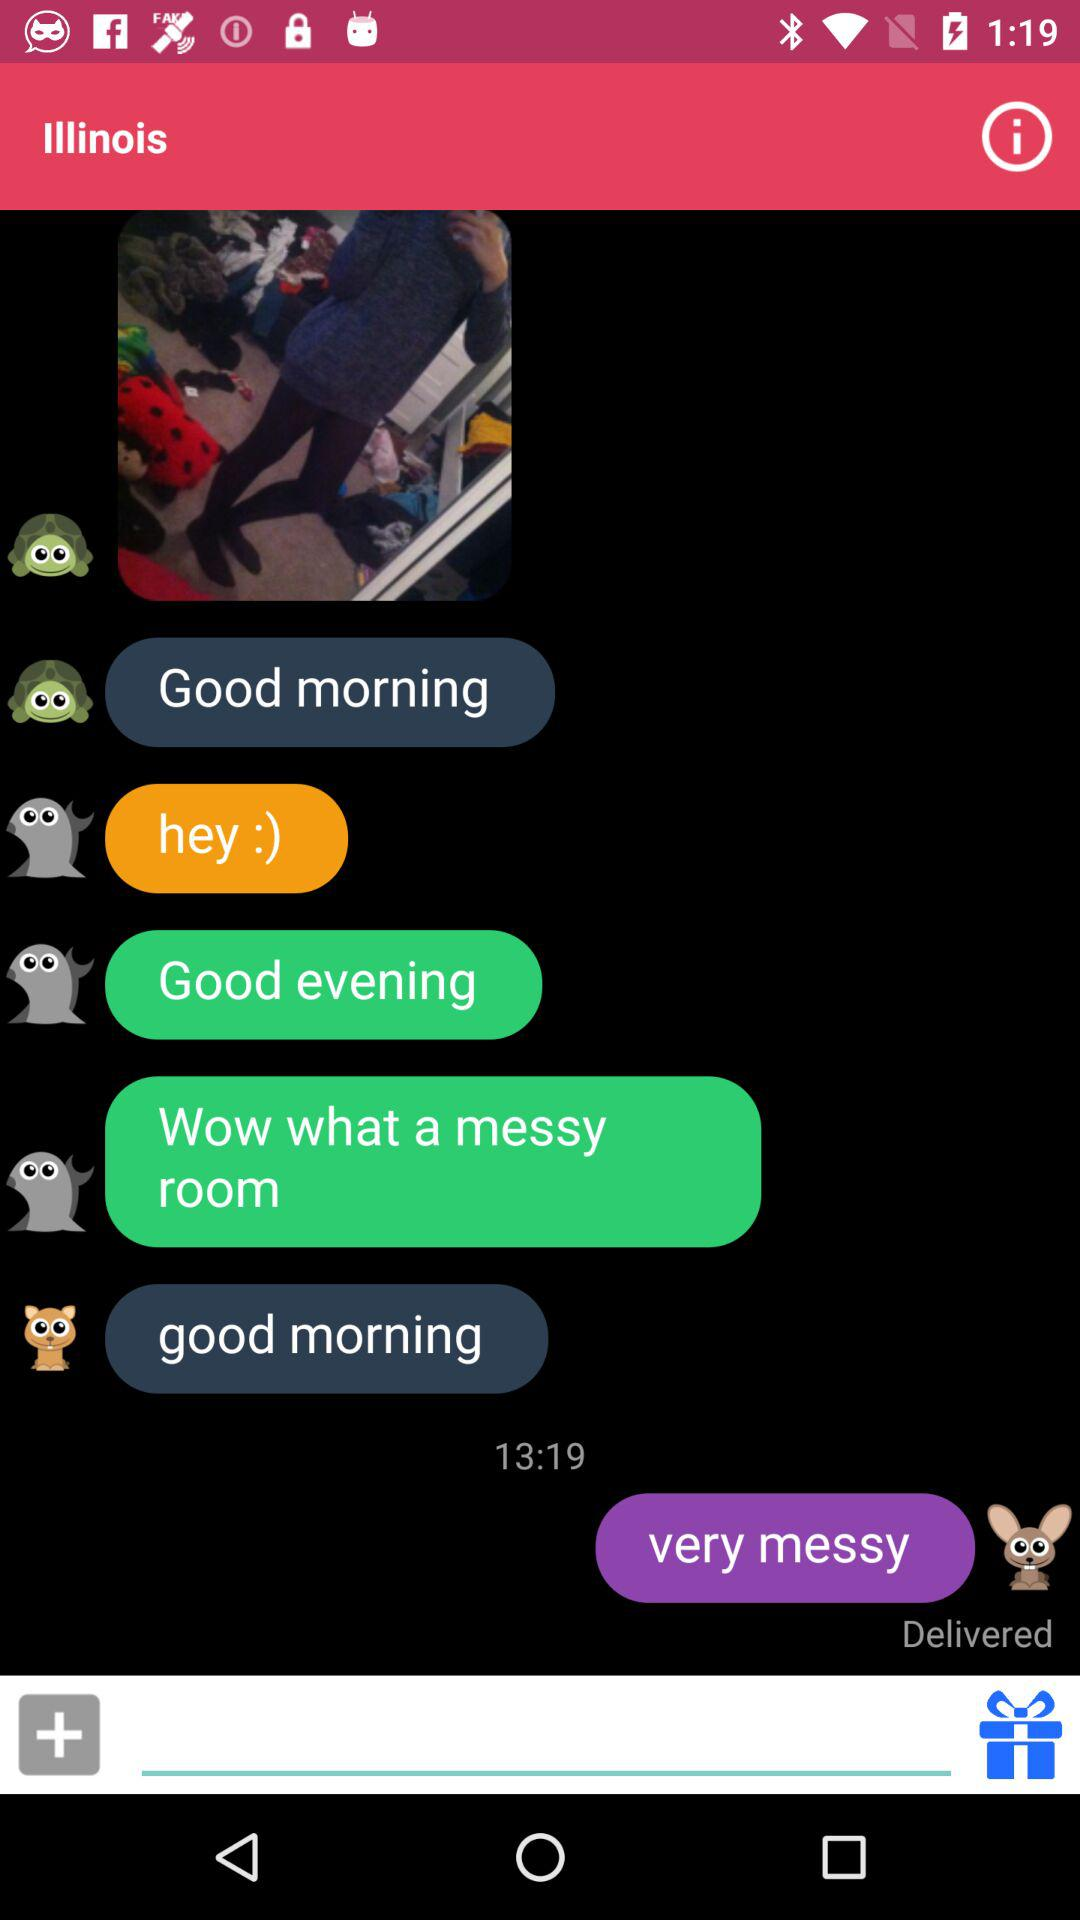What is the mentioned state? The mentioned state is Illinois. 